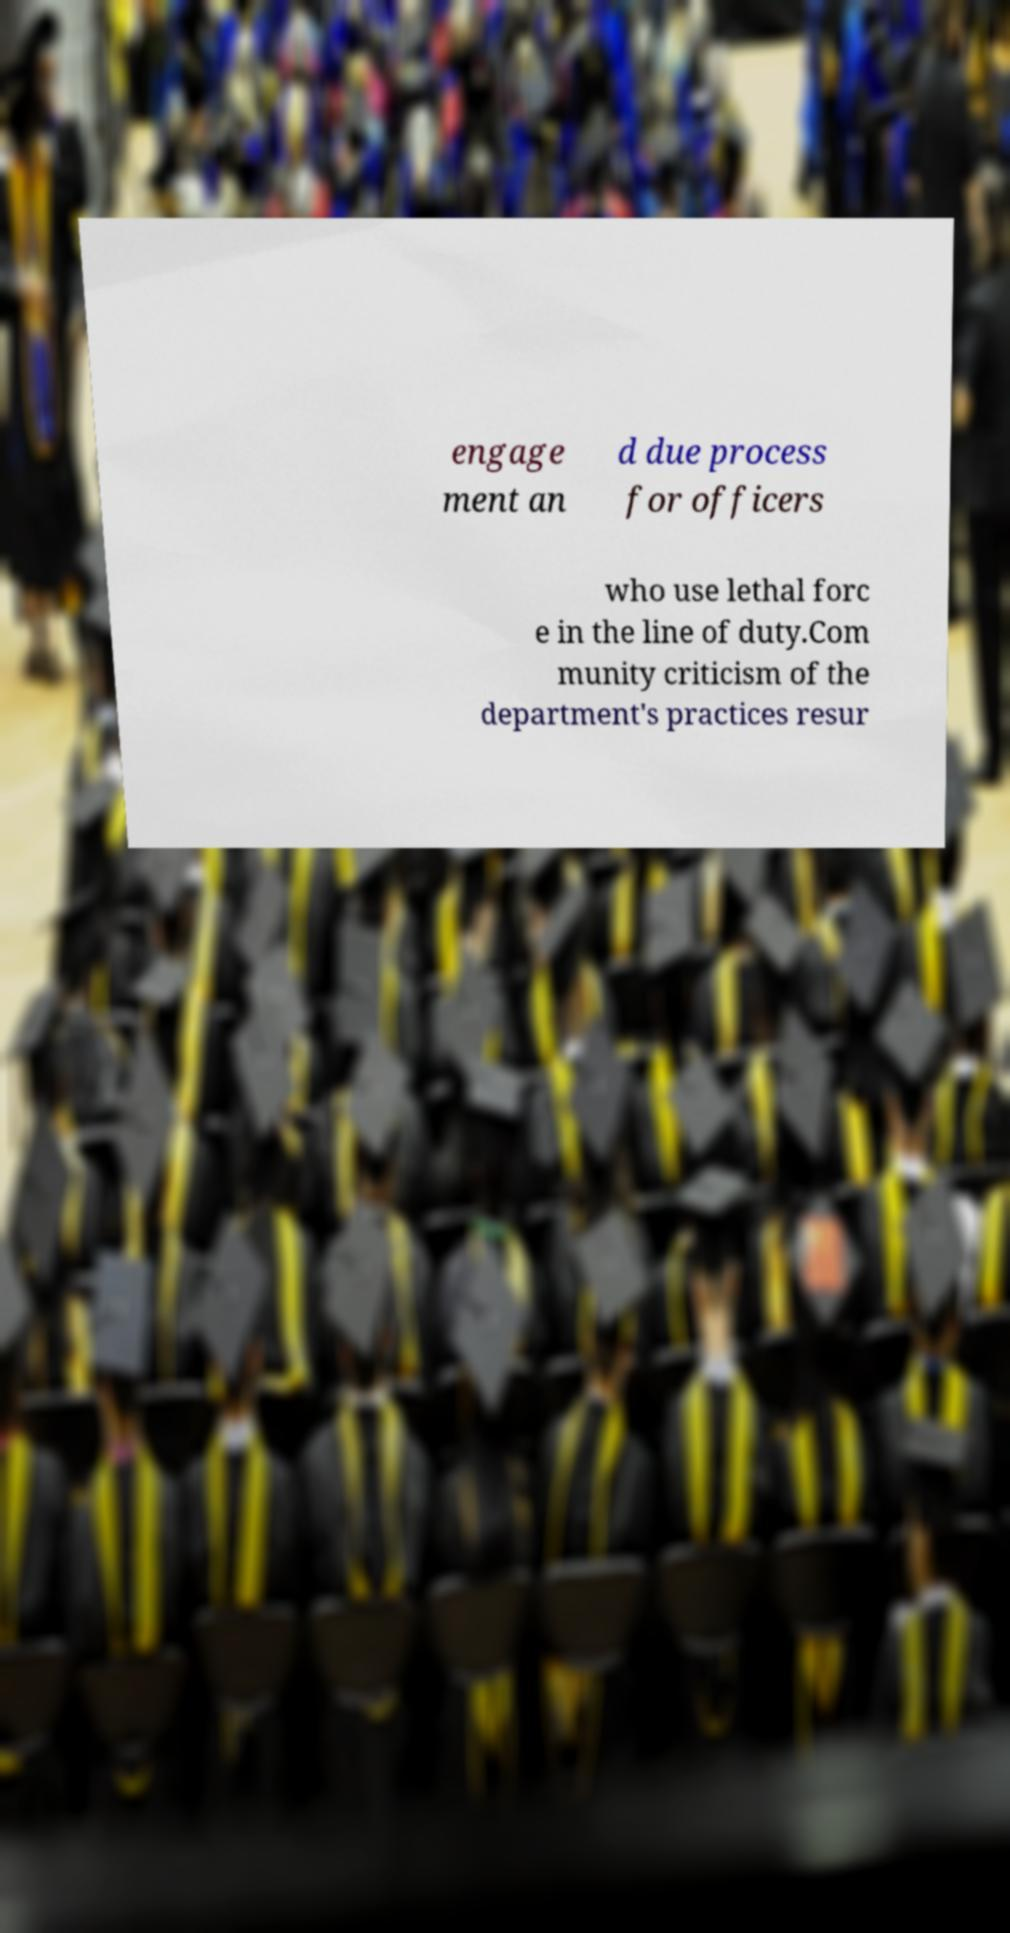Please read and relay the text visible in this image. What does it say? engage ment an d due process for officers who use lethal forc e in the line of duty.Com munity criticism of the department's practices resur 